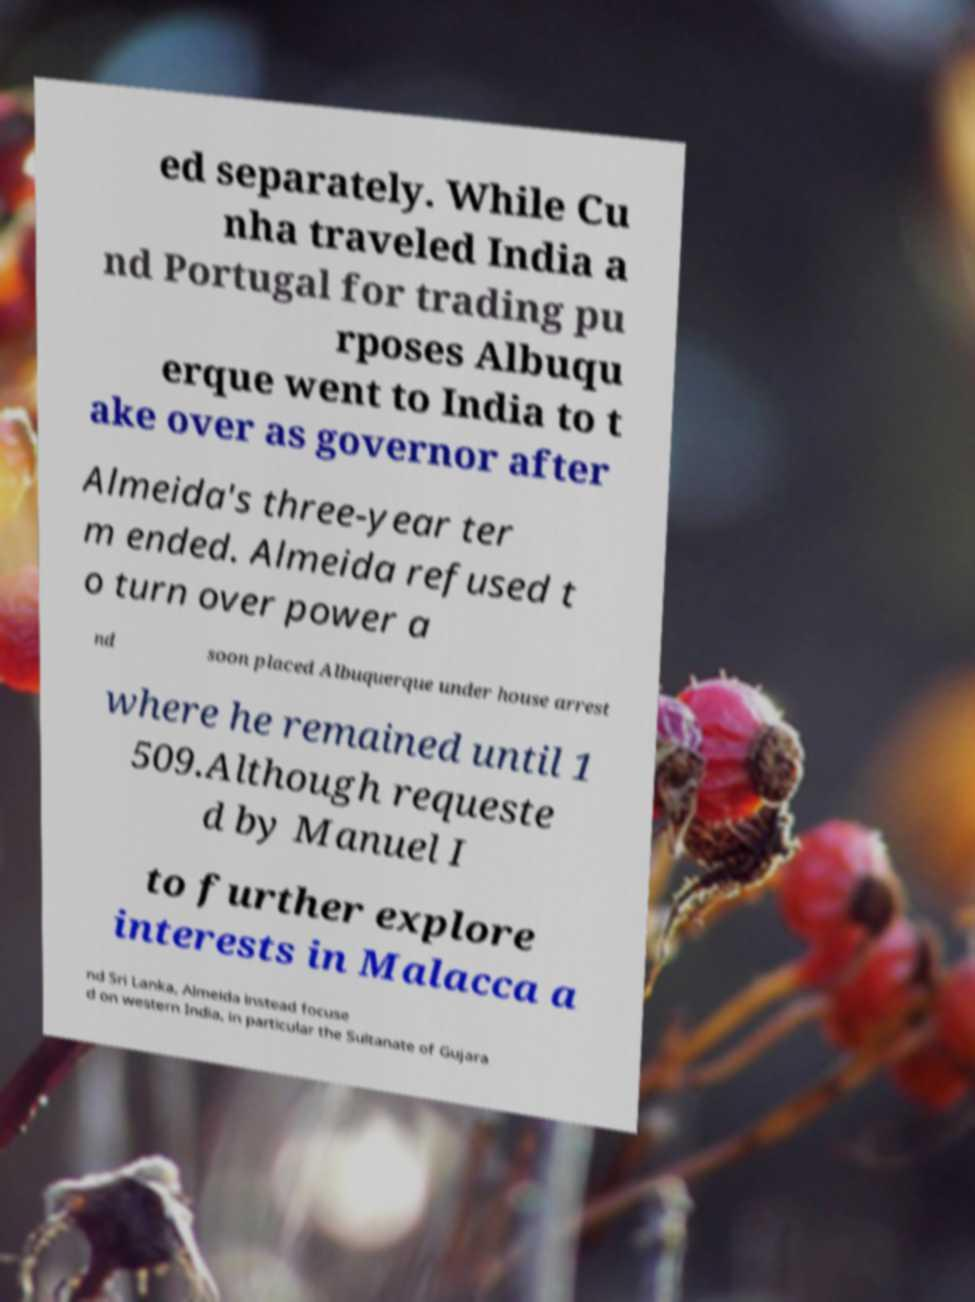Could you extract and type out the text from this image? ed separately. While Cu nha traveled India a nd Portugal for trading pu rposes Albuqu erque went to India to t ake over as governor after Almeida's three-year ter m ended. Almeida refused t o turn over power a nd soon placed Albuquerque under house arrest where he remained until 1 509.Although requeste d by Manuel I to further explore interests in Malacca a nd Sri Lanka, Almeida instead focuse d on western India, in particular the Sultanate of Gujara 